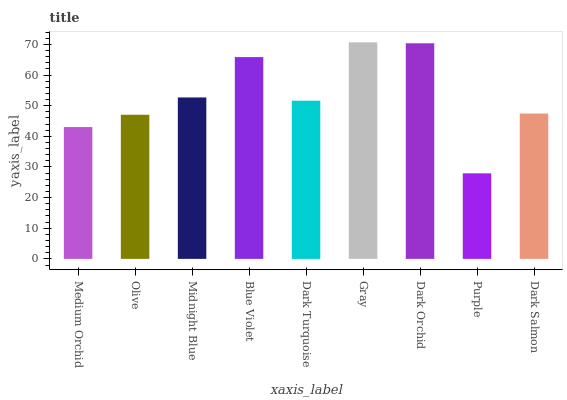Is Purple the minimum?
Answer yes or no. Yes. Is Gray the maximum?
Answer yes or no. Yes. Is Olive the minimum?
Answer yes or no. No. Is Olive the maximum?
Answer yes or no. No. Is Olive greater than Medium Orchid?
Answer yes or no. Yes. Is Medium Orchid less than Olive?
Answer yes or no. Yes. Is Medium Orchid greater than Olive?
Answer yes or no. No. Is Olive less than Medium Orchid?
Answer yes or no. No. Is Dark Turquoise the high median?
Answer yes or no. Yes. Is Dark Turquoise the low median?
Answer yes or no. Yes. Is Medium Orchid the high median?
Answer yes or no. No. Is Blue Violet the low median?
Answer yes or no. No. 